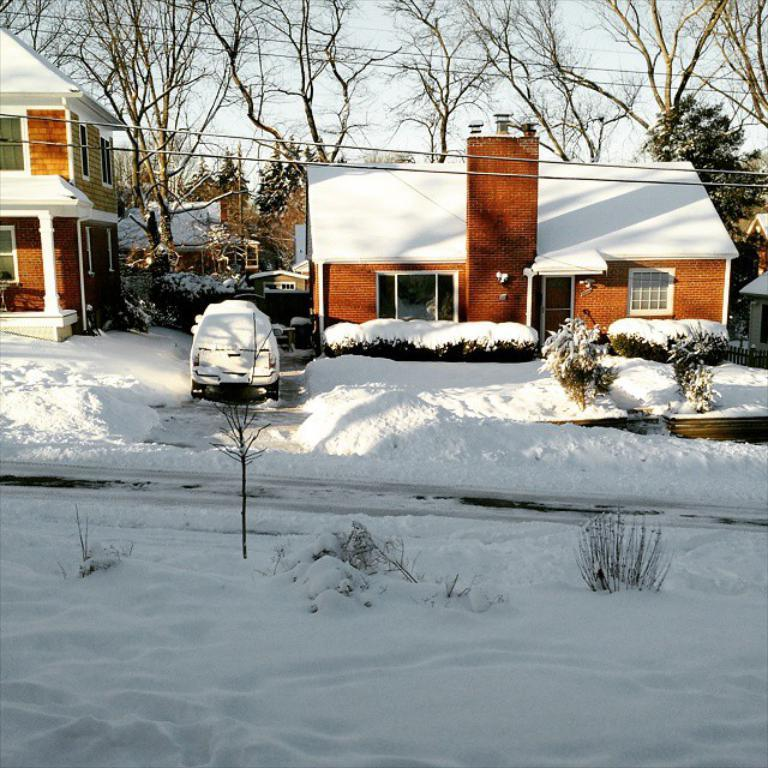What can be seen at the center of the image? There are buildings and trees at the center of the image. What is the condition of the vehicle in front of the building? The vehicle is covered with snow in front of the building. What is visible in the background of the image? The sky is visible in the background of the image. Can you describe the feeling of the cloth in the image? There is no cloth present in the image, so it is not possible to describe its feeling. 